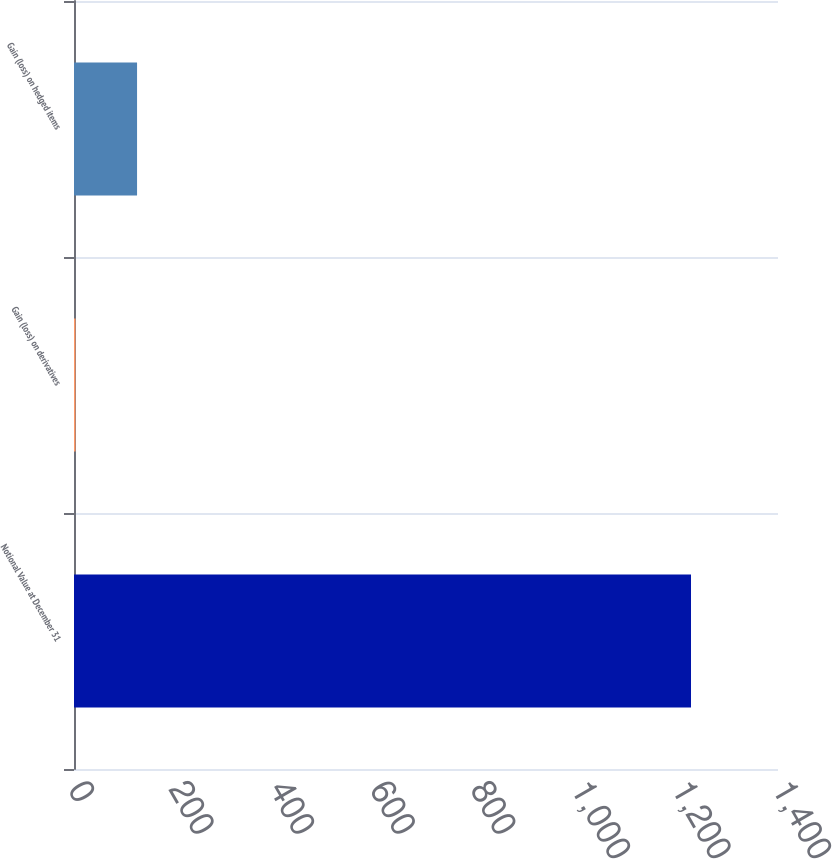Convert chart to OTSL. <chart><loc_0><loc_0><loc_500><loc_500><bar_chart><fcel>Notional Value at December 31<fcel>Gain (loss) on derivatives<fcel>Gain (loss) on hedged items<nl><fcel>1227<fcel>3<fcel>125.4<nl></chart> 